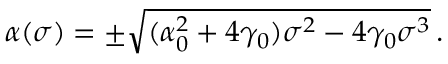Convert formula to latex. <formula><loc_0><loc_0><loc_500><loc_500>\alpha ( \sigma ) = \pm \sqrt { ( \alpha _ { 0 } ^ { 2 } + 4 \gamma _ { 0 } ) \sigma ^ { 2 } - 4 \gamma _ { 0 } \sigma ^ { 3 } } \, .</formula> 